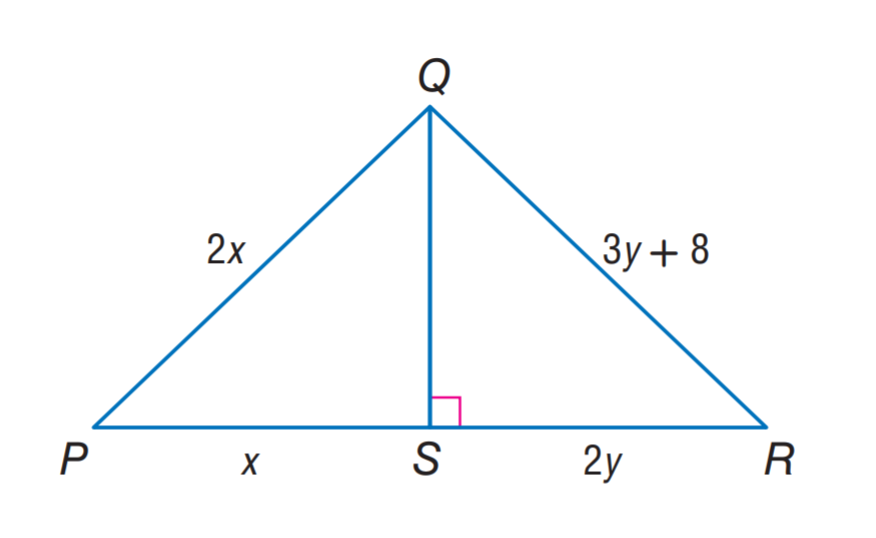Answer the mathemtical geometry problem and directly provide the correct option letter.
Question: \triangle P Q S \cong \triangle R Q S. Find y.
Choices: A: 8 B: 12 C: 16 D: 20 A 